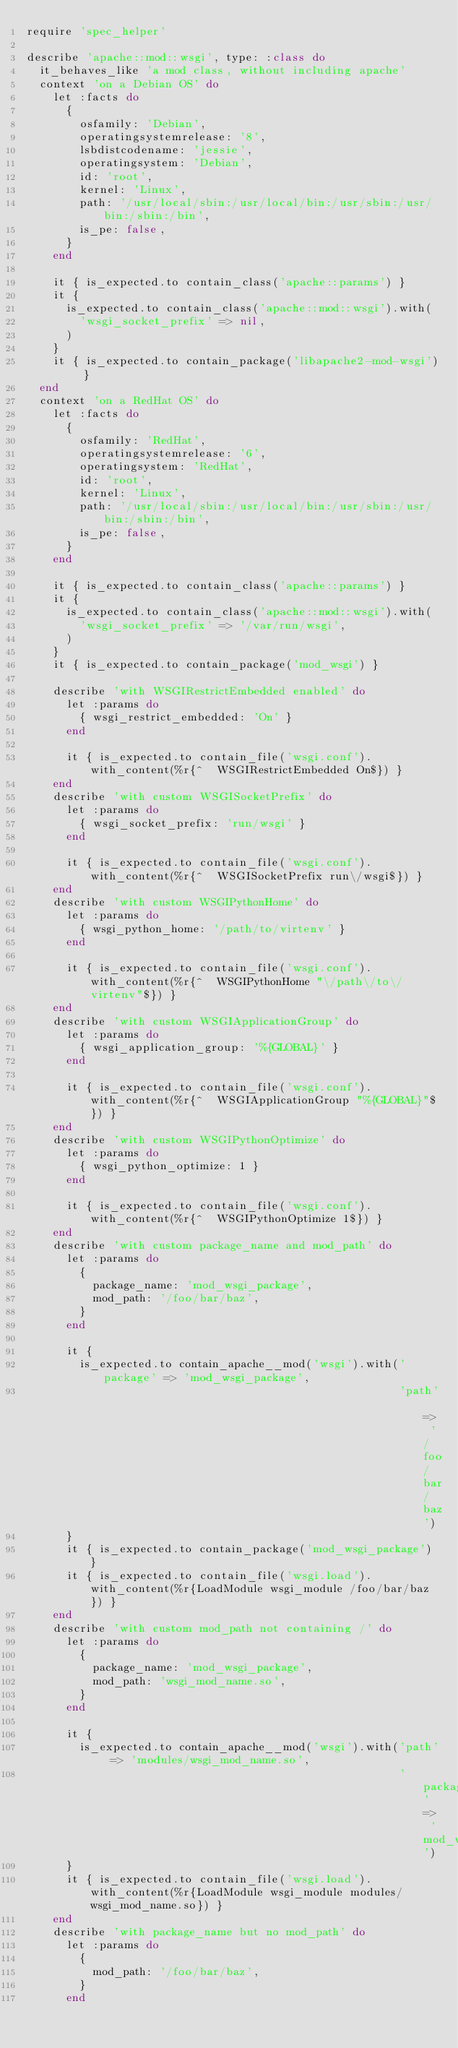<code> <loc_0><loc_0><loc_500><loc_500><_Ruby_>require 'spec_helper'

describe 'apache::mod::wsgi', type: :class do
  it_behaves_like 'a mod class, without including apache'
  context 'on a Debian OS' do
    let :facts do
      {
        osfamily: 'Debian',
        operatingsystemrelease: '8',
        lsbdistcodename: 'jessie',
        operatingsystem: 'Debian',
        id: 'root',
        kernel: 'Linux',
        path: '/usr/local/sbin:/usr/local/bin:/usr/sbin:/usr/bin:/sbin:/bin',
        is_pe: false,
      }
    end

    it { is_expected.to contain_class('apache::params') }
    it {
      is_expected.to contain_class('apache::mod::wsgi').with(
        'wsgi_socket_prefix' => nil,
      )
    }
    it { is_expected.to contain_package('libapache2-mod-wsgi') }
  end
  context 'on a RedHat OS' do
    let :facts do
      {
        osfamily: 'RedHat',
        operatingsystemrelease: '6',
        operatingsystem: 'RedHat',
        id: 'root',
        kernel: 'Linux',
        path: '/usr/local/sbin:/usr/local/bin:/usr/sbin:/usr/bin:/sbin:/bin',
        is_pe: false,
      }
    end

    it { is_expected.to contain_class('apache::params') }
    it {
      is_expected.to contain_class('apache::mod::wsgi').with(
        'wsgi_socket_prefix' => '/var/run/wsgi',
      )
    }
    it { is_expected.to contain_package('mod_wsgi') }

    describe 'with WSGIRestrictEmbedded enabled' do
      let :params do
        { wsgi_restrict_embedded: 'On' }
      end

      it { is_expected.to contain_file('wsgi.conf').with_content(%r{^  WSGIRestrictEmbedded On$}) }
    end
    describe 'with custom WSGISocketPrefix' do
      let :params do
        { wsgi_socket_prefix: 'run/wsgi' }
      end

      it { is_expected.to contain_file('wsgi.conf').with_content(%r{^  WSGISocketPrefix run\/wsgi$}) }
    end
    describe 'with custom WSGIPythonHome' do
      let :params do
        { wsgi_python_home: '/path/to/virtenv' }
      end

      it { is_expected.to contain_file('wsgi.conf').with_content(%r{^  WSGIPythonHome "\/path\/to\/virtenv"$}) }
    end
    describe 'with custom WSGIApplicationGroup' do
      let :params do
        { wsgi_application_group: '%{GLOBAL}' }
      end

      it { is_expected.to contain_file('wsgi.conf').with_content(%r{^  WSGIApplicationGroup "%{GLOBAL}"$}) }
    end
    describe 'with custom WSGIPythonOptimize' do
      let :params do
        { wsgi_python_optimize: 1 }
      end

      it { is_expected.to contain_file('wsgi.conf').with_content(%r{^  WSGIPythonOptimize 1$}) }
    end
    describe 'with custom package_name and mod_path' do
      let :params do
        {
          package_name: 'mod_wsgi_package',
          mod_path: '/foo/bar/baz',
        }
      end

      it {
        is_expected.to contain_apache__mod('wsgi').with('package' => 'mod_wsgi_package',
                                                        'path' => '/foo/bar/baz')
      }
      it { is_expected.to contain_package('mod_wsgi_package') }
      it { is_expected.to contain_file('wsgi.load').with_content(%r{LoadModule wsgi_module /foo/bar/baz}) }
    end
    describe 'with custom mod_path not containing /' do
      let :params do
        {
          package_name: 'mod_wsgi_package',
          mod_path: 'wsgi_mod_name.so',
        }
      end

      it {
        is_expected.to contain_apache__mod('wsgi').with('path' => 'modules/wsgi_mod_name.so',
                                                        'package' => 'mod_wsgi_package')
      }
      it { is_expected.to contain_file('wsgi.load').with_content(%r{LoadModule wsgi_module modules/wsgi_mod_name.so}) }
    end
    describe 'with package_name but no mod_path' do
      let :params do
        {
          mod_path: '/foo/bar/baz',
        }
      end
</code> 